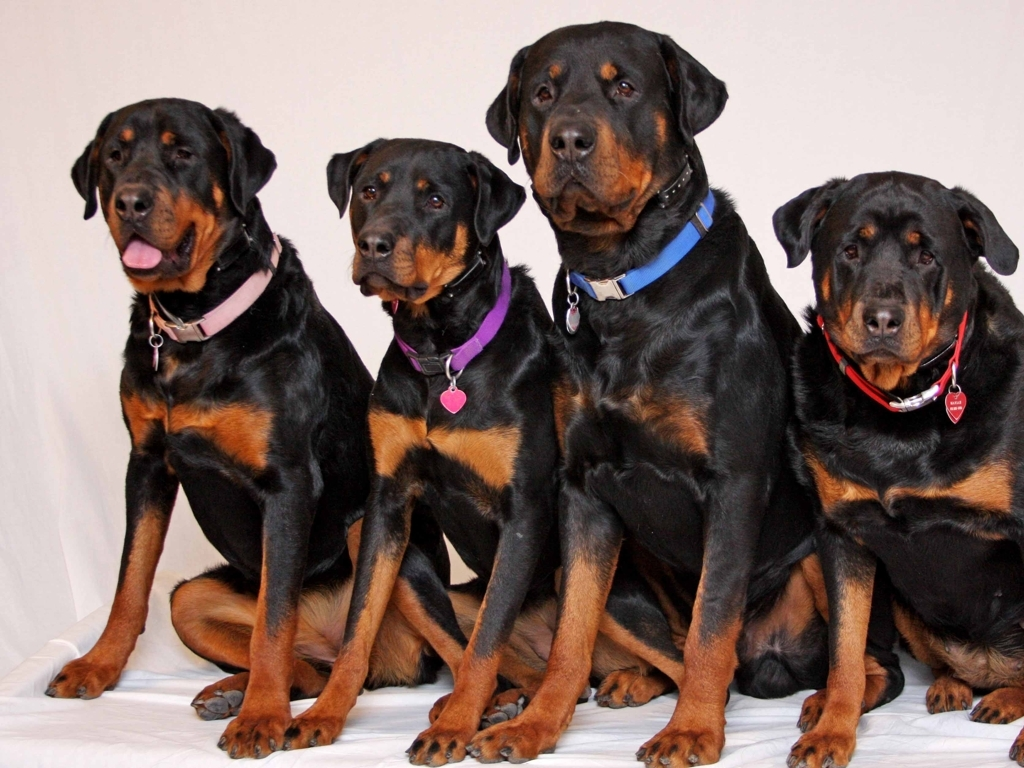Can you tell me about the temperament of the dogs in this image? Certainly! Rottweilers, like the ones in the image, are known for their confident and fearless personalities. They tend to be obedient and have a natural inclination to protect their home and family. These dogs require training and socialization from a young age to ensure they develop a well-balanced temperament. Despite their imposing appearance, they can be loving and loyal companions within their family unit. 